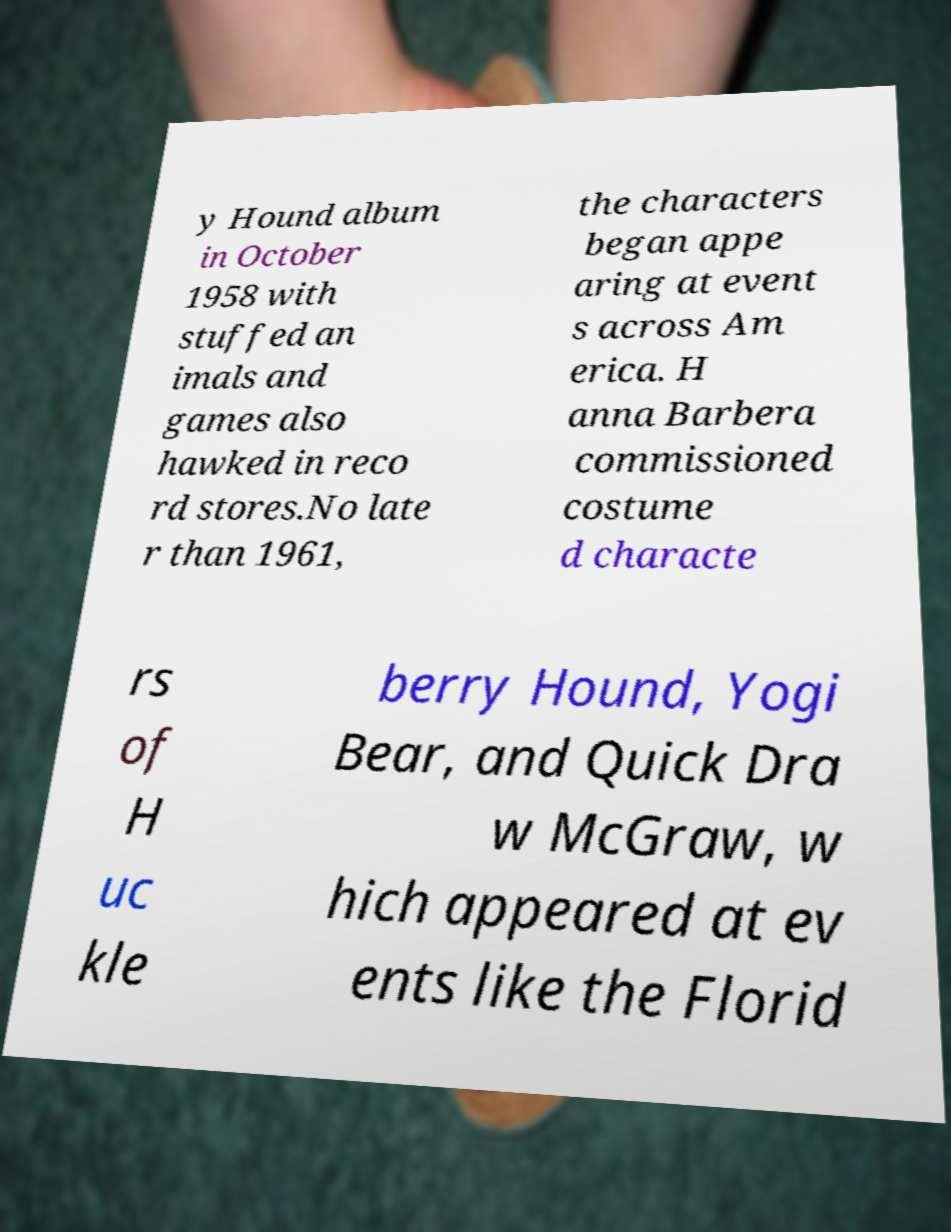There's text embedded in this image that I need extracted. Can you transcribe it verbatim? y Hound album in October 1958 with stuffed an imals and games also hawked in reco rd stores.No late r than 1961, the characters began appe aring at event s across Am erica. H anna Barbera commissioned costume d characte rs of H uc kle berry Hound, Yogi Bear, and Quick Dra w McGraw, w hich appeared at ev ents like the Florid 